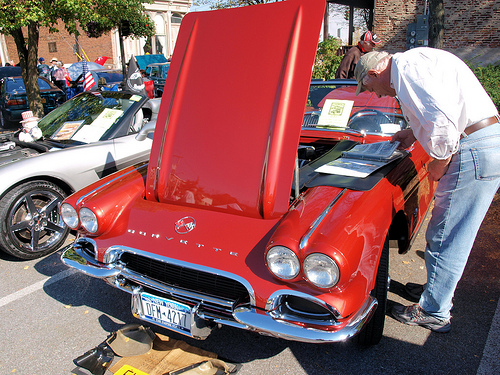<image>
Is the book on the car? Yes. Looking at the image, I can see the book is positioned on top of the car, with the car providing support. Is the man to the left of the car? No. The man is not to the left of the car. From this viewpoint, they have a different horizontal relationship. 